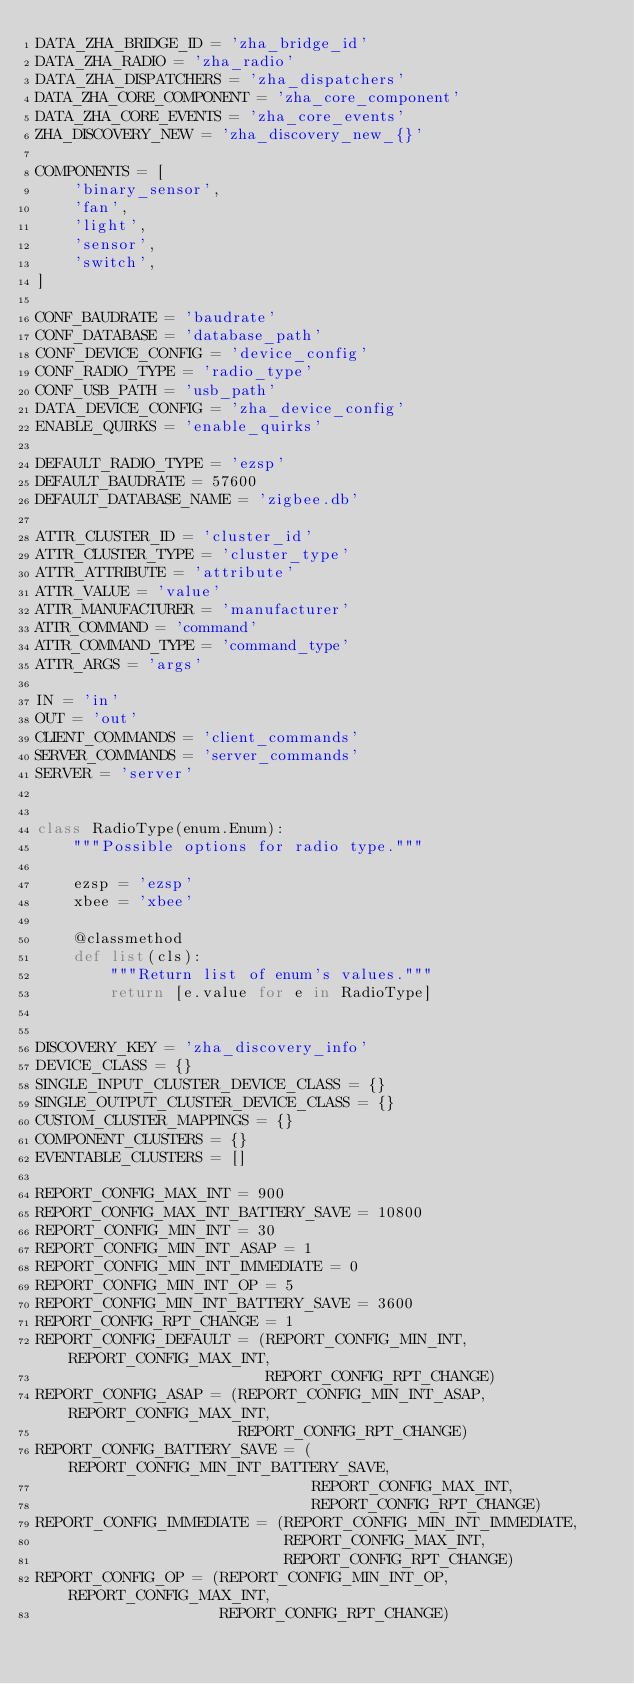<code> <loc_0><loc_0><loc_500><loc_500><_Python_>DATA_ZHA_BRIDGE_ID = 'zha_bridge_id'
DATA_ZHA_RADIO = 'zha_radio'
DATA_ZHA_DISPATCHERS = 'zha_dispatchers'
DATA_ZHA_CORE_COMPONENT = 'zha_core_component'
DATA_ZHA_CORE_EVENTS = 'zha_core_events'
ZHA_DISCOVERY_NEW = 'zha_discovery_new_{}'

COMPONENTS = [
    'binary_sensor',
    'fan',
    'light',
    'sensor',
    'switch',
]

CONF_BAUDRATE = 'baudrate'
CONF_DATABASE = 'database_path'
CONF_DEVICE_CONFIG = 'device_config'
CONF_RADIO_TYPE = 'radio_type'
CONF_USB_PATH = 'usb_path'
DATA_DEVICE_CONFIG = 'zha_device_config'
ENABLE_QUIRKS = 'enable_quirks'

DEFAULT_RADIO_TYPE = 'ezsp'
DEFAULT_BAUDRATE = 57600
DEFAULT_DATABASE_NAME = 'zigbee.db'

ATTR_CLUSTER_ID = 'cluster_id'
ATTR_CLUSTER_TYPE = 'cluster_type'
ATTR_ATTRIBUTE = 'attribute'
ATTR_VALUE = 'value'
ATTR_MANUFACTURER = 'manufacturer'
ATTR_COMMAND = 'command'
ATTR_COMMAND_TYPE = 'command_type'
ATTR_ARGS = 'args'

IN = 'in'
OUT = 'out'
CLIENT_COMMANDS = 'client_commands'
SERVER_COMMANDS = 'server_commands'
SERVER = 'server'


class RadioType(enum.Enum):
    """Possible options for radio type."""

    ezsp = 'ezsp'
    xbee = 'xbee'

    @classmethod
    def list(cls):
        """Return list of enum's values."""
        return [e.value for e in RadioType]


DISCOVERY_KEY = 'zha_discovery_info'
DEVICE_CLASS = {}
SINGLE_INPUT_CLUSTER_DEVICE_CLASS = {}
SINGLE_OUTPUT_CLUSTER_DEVICE_CLASS = {}
CUSTOM_CLUSTER_MAPPINGS = {}
COMPONENT_CLUSTERS = {}
EVENTABLE_CLUSTERS = []

REPORT_CONFIG_MAX_INT = 900
REPORT_CONFIG_MAX_INT_BATTERY_SAVE = 10800
REPORT_CONFIG_MIN_INT = 30
REPORT_CONFIG_MIN_INT_ASAP = 1
REPORT_CONFIG_MIN_INT_IMMEDIATE = 0
REPORT_CONFIG_MIN_INT_OP = 5
REPORT_CONFIG_MIN_INT_BATTERY_SAVE = 3600
REPORT_CONFIG_RPT_CHANGE = 1
REPORT_CONFIG_DEFAULT = (REPORT_CONFIG_MIN_INT, REPORT_CONFIG_MAX_INT,
                         REPORT_CONFIG_RPT_CHANGE)
REPORT_CONFIG_ASAP = (REPORT_CONFIG_MIN_INT_ASAP, REPORT_CONFIG_MAX_INT,
                      REPORT_CONFIG_RPT_CHANGE)
REPORT_CONFIG_BATTERY_SAVE = (REPORT_CONFIG_MIN_INT_BATTERY_SAVE,
                              REPORT_CONFIG_MAX_INT,
                              REPORT_CONFIG_RPT_CHANGE)
REPORT_CONFIG_IMMEDIATE = (REPORT_CONFIG_MIN_INT_IMMEDIATE,
                           REPORT_CONFIG_MAX_INT,
                           REPORT_CONFIG_RPT_CHANGE)
REPORT_CONFIG_OP = (REPORT_CONFIG_MIN_INT_OP, REPORT_CONFIG_MAX_INT,
                    REPORT_CONFIG_RPT_CHANGE)
</code> 